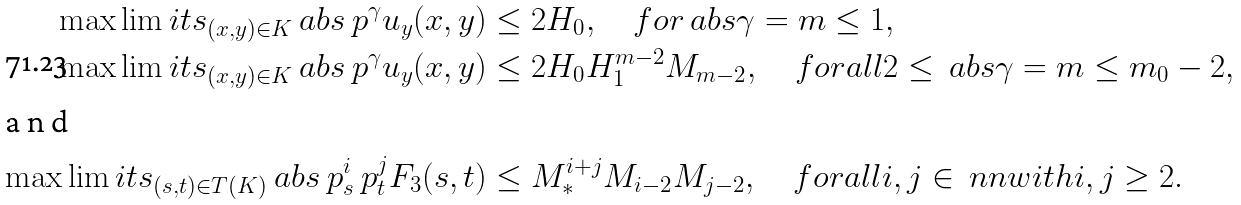Convert formula to latex. <formula><loc_0><loc_0><loc_500><loc_500>\max \lim i t s _ { ( x , y ) \in K } \ a b s { \ p ^ { \gamma } u _ { y } ( x , y ) } & \leq 2 H _ { 0 } , \quad f o r \ a b s \gamma = m \leq 1 , \\ \max \lim i t s _ { ( x , y ) \in K } \ a b s { \ p ^ { \gamma } u _ { y } ( x , y ) } & \leq 2 H _ { 0 } H _ { 1 } ^ { m - 2 } M _ { m - 2 } , \quad f o r a l l 2 \leq \ a b s \gamma = m \leq m _ { 0 } - 2 , \\ \intertext { a n d } \max \lim i t s _ { ( s , t ) \in T ( K ) } \ a b s { \ p _ { s } ^ { i } \ p _ { t } ^ { j } F _ { 3 } ( s , t ) } & \leq M _ { * } ^ { i + j } M _ { i - 2 } M _ { j - 2 } , \quad f o r a l l i , j \in \ n n w i t h i , j \geq 2 .</formula> 